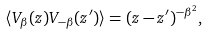<formula> <loc_0><loc_0><loc_500><loc_500>\langle V _ { \beta } ( z ) V _ { - \beta } ( z ^ { \prime } ) \rangle = ( z - z ^ { \prime } ) ^ { - \beta ^ { 2 } } ,</formula> 